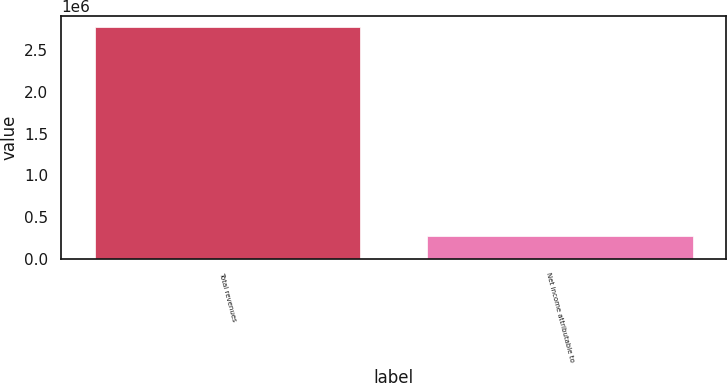<chart> <loc_0><loc_0><loc_500><loc_500><bar_chart><fcel>Total revenues<fcel>Net income attributable to<nl><fcel>2.77372e+06<fcel>278040<nl></chart> 